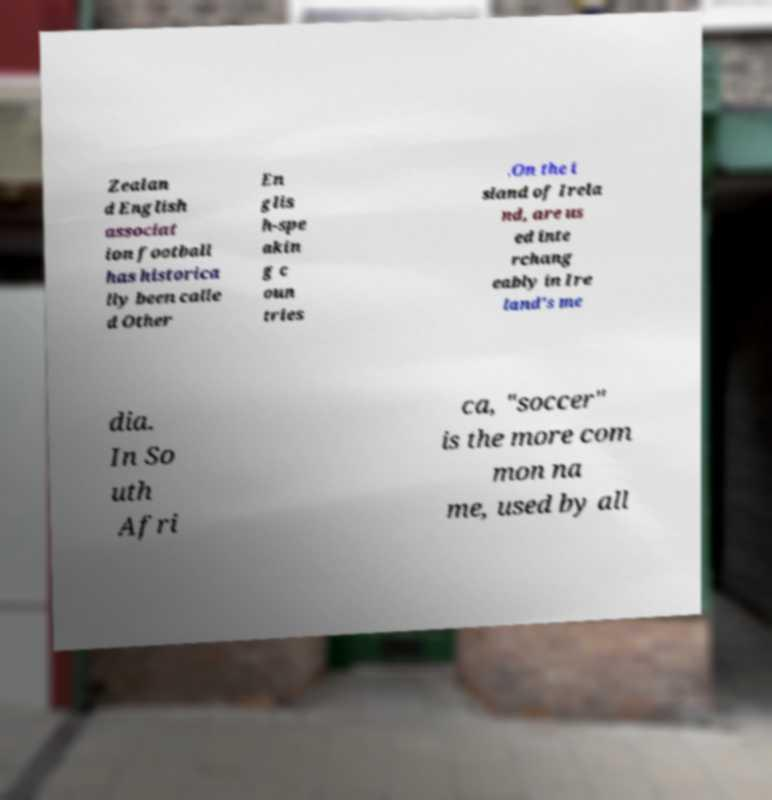For documentation purposes, I need the text within this image transcribed. Could you provide that? Zealan d English associat ion football has historica lly been calle d Other En glis h-spe akin g c oun tries .On the i sland of Irela nd, are us ed inte rchang eably in Ire land's me dia. In So uth Afri ca, "soccer" is the more com mon na me, used by all 